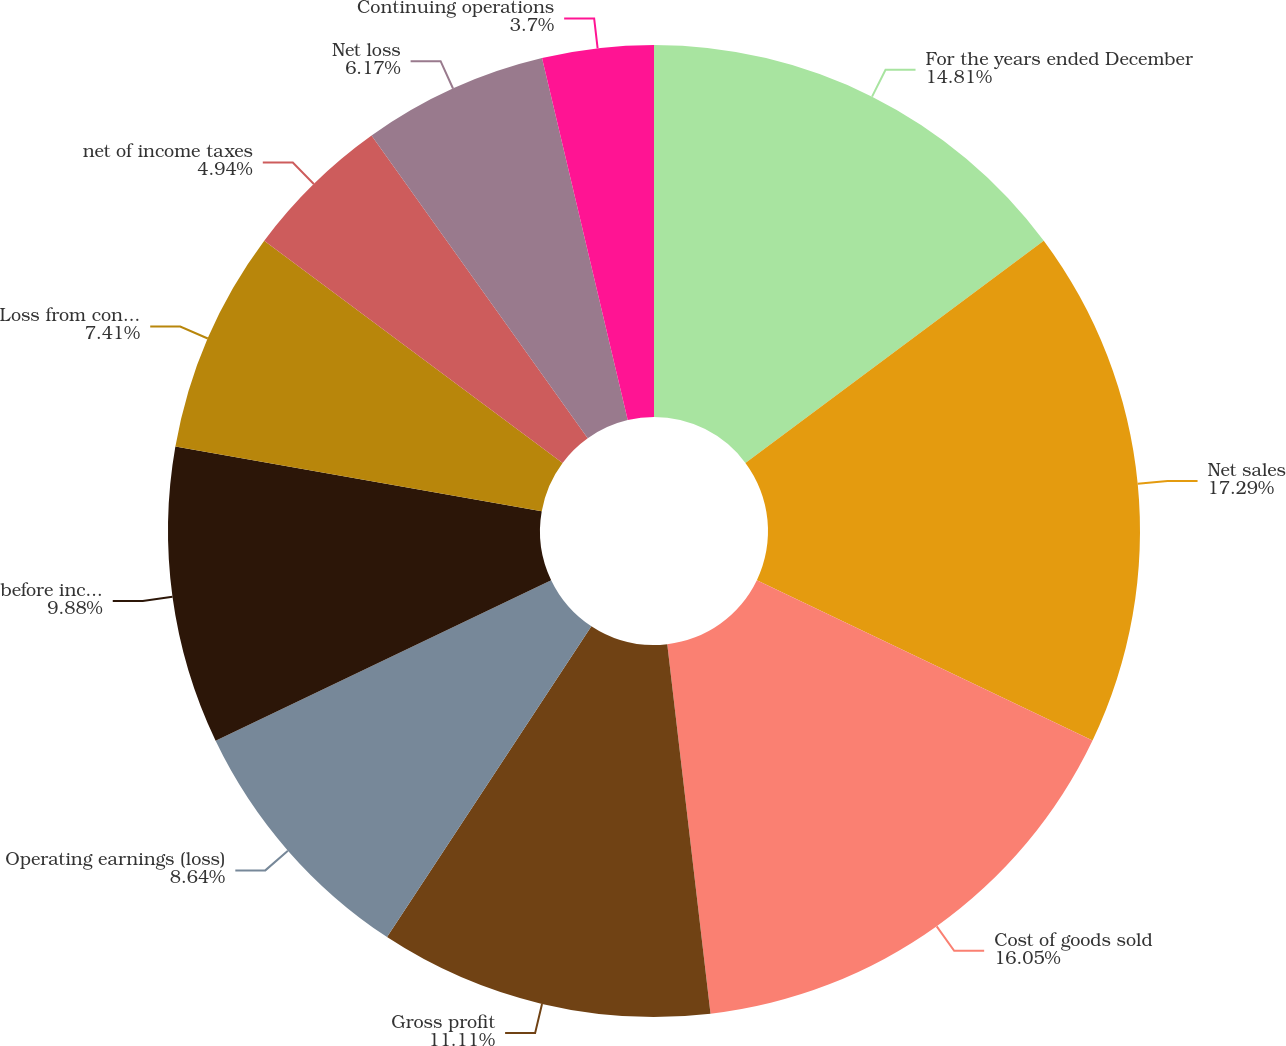Convert chart. <chart><loc_0><loc_0><loc_500><loc_500><pie_chart><fcel>For the years ended December<fcel>Net sales<fcel>Cost of goods sold<fcel>Gross profit<fcel>Operating earnings (loss)<fcel>before income taxes<fcel>Loss from continuing<fcel>net of income taxes<fcel>Net loss<fcel>Continuing operations<nl><fcel>14.81%<fcel>17.28%<fcel>16.05%<fcel>11.11%<fcel>8.64%<fcel>9.88%<fcel>7.41%<fcel>4.94%<fcel>6.17%<fcel>3.7%<nl></chart> 